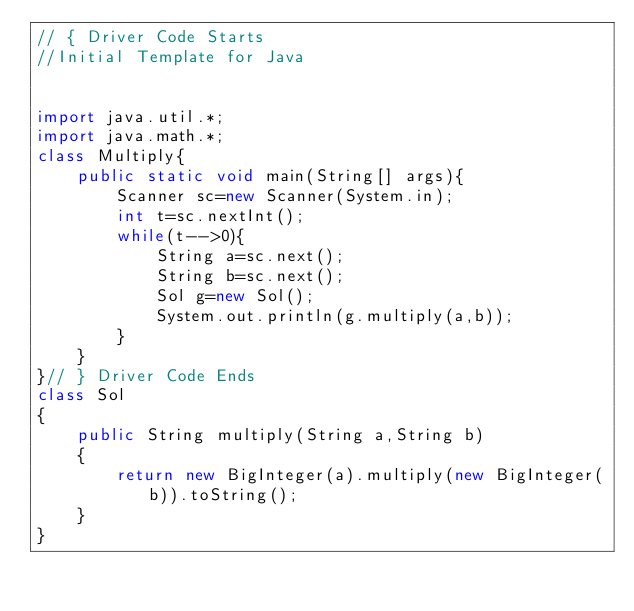Convert code to text. <code><loc_0><loc_0><loc_500><loc_500><_Java_>// { Driver Code Starts
//Initial Template for Java


import java.util.*;
import java.math.*;
class Multiply{
    public static void main(String[] args){
        Scanner sc=new Scanner(System.in);
        int t=sc.nextInt();
        while(t-->0){
            String a=sc.next();
            String b=sc.next();
            Sol g=new Sol();
            System.out.println(g.multiply(a,b));
        }
    }
}// } Driver Code Ends
class Sol
{
    public String multiply(String a,String b)
    {
        return new BigInteger(a).multiply(new BigInteger(b)).toString();
    }
}</code> 